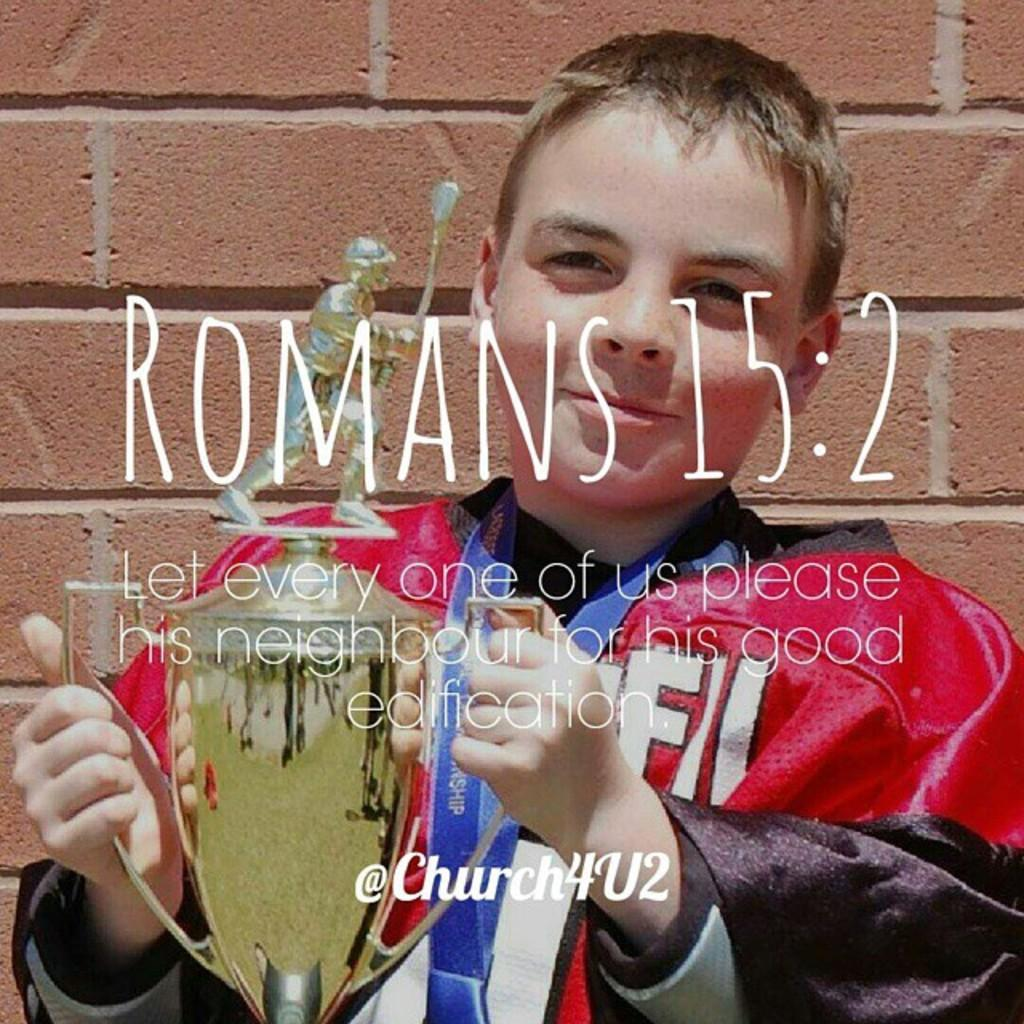<image>
Summarize the visual content of the image. A bible verse on a picture titled "Romans 15:2" 